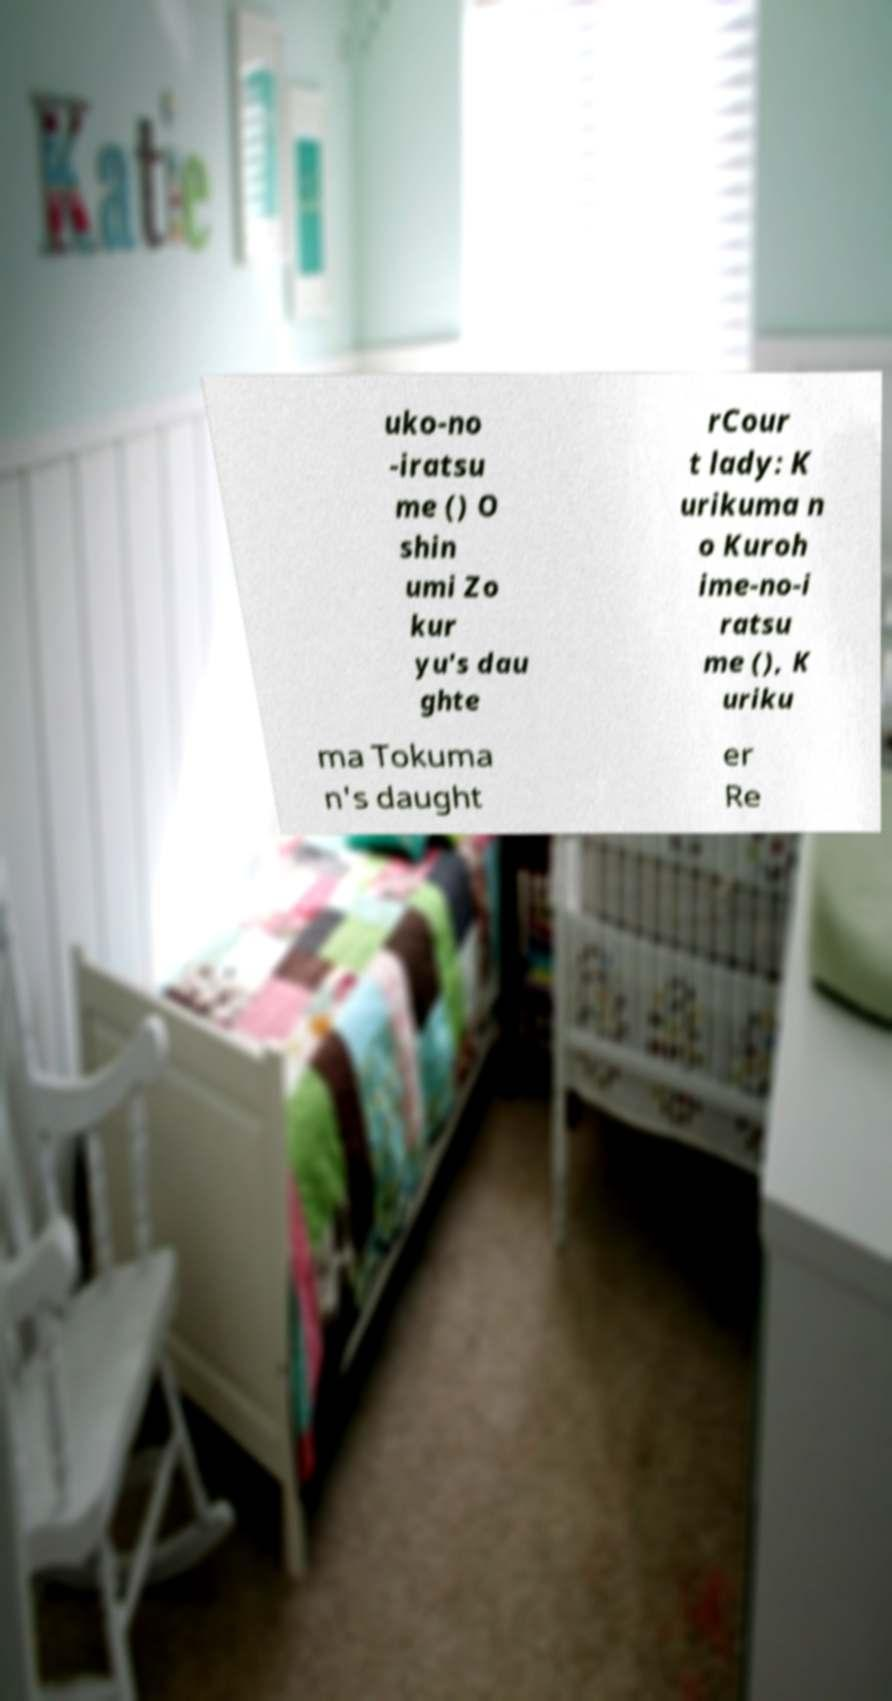I need the written content from this picture converted into text. Can you do that? uko-no -iratsu me () O shin umi Zo kur yu's dau ghte rCour t lady: K urikuma n o Kuroh ime-no-i ratsu me (), K uriku ma Tokuma n's daught er Re 